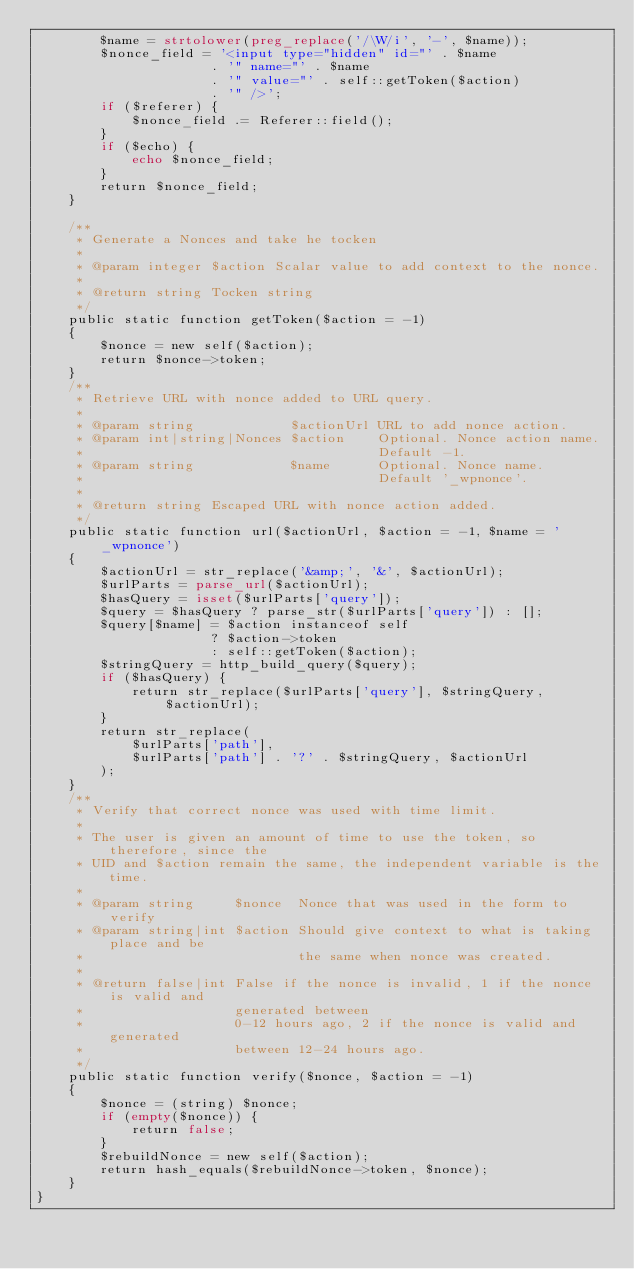Convert code to text. <code><loc_0><loc_0><loc_500><loc_500><_PHP_>        $name = strtolower(preg_replace('/\W/i', '-', $name));
        $nonce_field = '<input type="hidden" id="' . $name
                      . '" name="' . $name
                      . '" value="' . self::getToken($action)
                      . '" />';
        if ($referer) {
            $nonce_field .= Referer::field();
        }
        if ($echo) {
            echo $nonce_field;
        }
        return $nonce_field;
    }

    /**
     * Generate a Nonces and take he tocken
     *
     * @param integer $action Scalar value to add context to the nonce.
     *
     * @return string Tocken string
     */
    public static function getToken($action = -1)
    {
        $nonce = new self($action);
        return $nonce->token;
    }
    /**
     * Retrieve URL with nonce added to URL query.
     *
     * @param string            $actionUrl URL to add nonce action.
     * @param int|string|Nonces $action    Optional. Nonce action name.
     *                                     Default -1.
     * @param string            $name      Optional. Nonce name.
     *                                     Default '_wpnonce'.
     *
     * @return string Escaped URL with nonce action added.
     */
    public static function url($actionUrl, $action = -1, $name = '_wpnonce')
    {
        $actionUrl = str_replace('&amp;', '&', $actionUrl);
        $urlParts = parse_url($actionUrl);
        $hasQuery = isset($urlParts['query']);
        $query = $hasQuery ? parse_str($urlParts['query']) : [];
        $query[$name] = $action instanceof self
                      ? $action->token
                      : self::getToken($action);
        $stringQuery = http_build_query($query);
        if ($hasQuery) {
            return str_replace($urlParts['query'], $stringQuery, $actionUrl);
        }
        return str_replace(
            $urlParts['path'],
            $urlParts['path'] . '?' . $stringQuery, $actionUrl
        );
    }
    /**
     * Verify that correct nonce was used with time limit.
     *
     * The user is given an amount of time to use the token, so therefore, since the
     * UID and $action remain the same, the independent variable is the time.
     *
     * @param string     $nonce  Nonce that was used in the form to verify
     * @param string|int $action Should give context to what is taking place and be
     *                           the same when nonce was created.
     *
     * @return false|int False if the nonce is invalid, 1 if the nonce is valid and
     *                   generated between
     *                   0-12 hours ago, 2 if the nonce is valid and generated
     *                   between 12-24 hours ago.
     */
    public static function verify($nonce, $action = -1)
    {
        $nonce = (string) $nonce;
        if (empty($nonce)) {
            return false;
        }
        $rebuildNonce = new self($action);
        return hash_equals($rebuildNonce->token, $nonce);
    }
}
</code> 